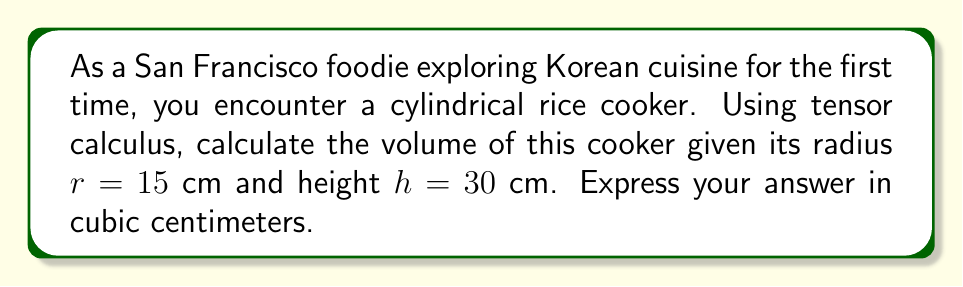Teach me how to tackle this problem. To calculate the volume of a cylindrical rice cooker using tensor calculus, we'll follow these steps:

1) In cylindrical coordinates $(r, \theta, z)$, the volume element is given by:
   $$dV = r \, dr \, d\theta \, dz$$

2) The volume of the cylinder is obtained by integrating this element over the entire region:
   $$V = \int_0^h \int_0^{2\pi} \int_0^r r \, dr \, d\theta \, dz$$

3) Let's evaluate the innermost integral first:
   $$\int_0^r r \, dr = \frac{1}{2}r^2$$

4) Now, our integral becomes:
   $$V = \int_0^h \int_0^{2\pi} \frac{1}{2}r^2 \, d\theta \, dz$$

5) Evaluating the $\theta$ integral:
   $$V = \int_0^h \pi r^2 \, dz$$

6) Since $r$ is constant (not dependent on $z$), we can treat $\pi r^2$ as a constant:
   $$V = \pi r^2 \int_0^h dz = \pi r^2 h$$

7) Substituting the given values $r = 15$ cm and $h = 30$ cm:
   $$V = \pi (15 \text{ cm})^2 (30 \text{ cm}) = 21195.44 \text{ cm}^3$$

8) Rounding to the nearest whole number:
   $$V \approx 21195 \text{ cm}^3$$
Answer: $21195 \text{ cm}^3$ 